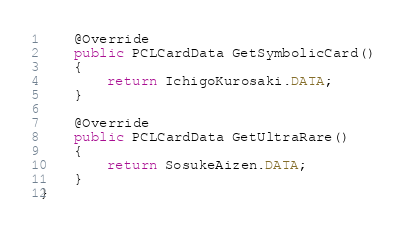Convert code to text. <code><loc_0><loc_0><loc_500><loc_500><_Java_>    @Override
    public PCLCardData GetSymbolicCard()
    {
        return IchigoKurosaki.DATA;
    }

    @Override
    public PCLCardData GetUltraRare()
    {
        return SosukeAizen.DATA;
    }
}
</code> 